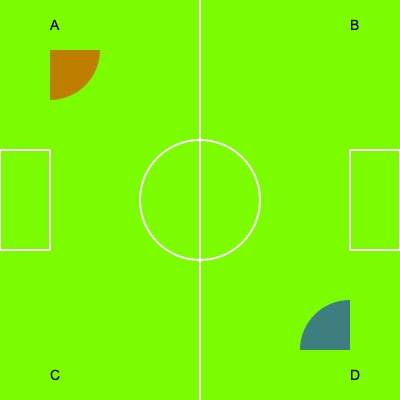In the Dutch-inspired positional play used by FC Barcelona, the pitch is often divided into zones. If the red-shaded corner area (A) is rotated 180° around the center of the pitch, which corner will it overlap with, and how might this rotation affect the tactical approach? To solve this problem, we need to follow these steps:

1. Identify the initial position: The red-shaded area is in corner A (top-left).

2. Understand the rotation:
   - 180° rotation around the center of the pitch
   - This means the area will move to the opposite side of the pitch

3. Determine the new position:
   - A 180° rotation will move the area from the top-left to the bottom-right
   - The red-shaded area will overlap with corner D

4. Tactical implications:
   - In Dutch-inspired positional play, corner areas are crucial for build-up play and creating width
   - The rotation demonstrates that tactics used in one corner can be mirrored in the opposite corner
   - This rotation highlights the importance of diagonal movements and switches of play in the Barcelona system
   - It shows how overloading one side (e.g., the left) can create space on the opposite side (right)
   - The blue-shaded area in corner D represents the space that could be exploited after switching play

5. Tactical approach changes:
   - Teams might adapt their pressing strategy to account for potential quick switches of play
   - Barcelona could use this principle to create numerical superiorities on one side before quickly transferring the ball to the opposite flank
   - This rotation principle underlines the importance of versatile players who can operate effectively in multiple zones of the pitch
Answer: Corner D; enhances diagonal play and switches of play 